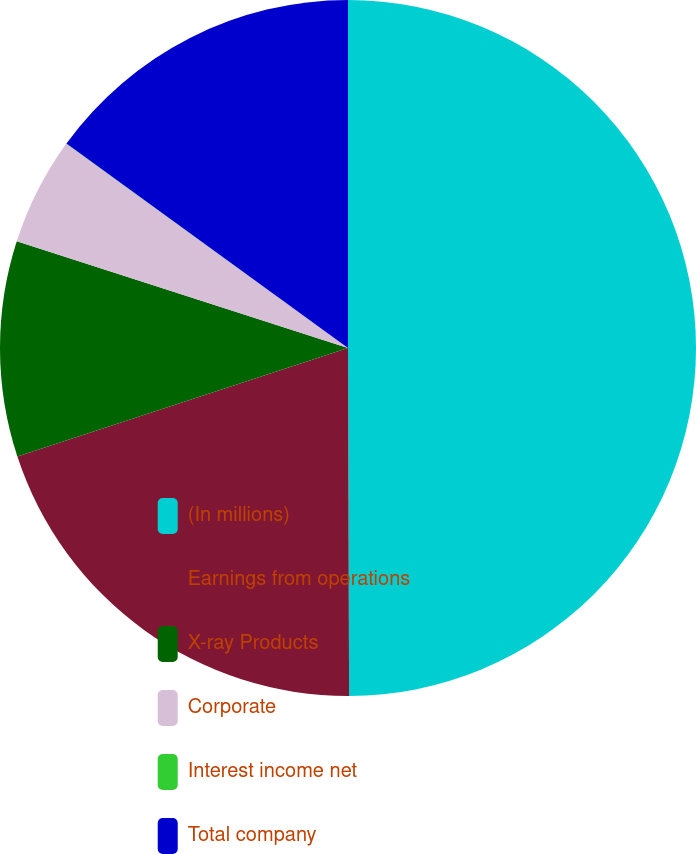Convert chart to OTSL. <chart><loc_0><loc_0><loc_500><loc_500><pie_chart><fcel>(In millions)<fcel>Earnings from operations<fcel>X-ray Products<fcel>Corporate<fcel>Interest income net<fcel>Total company<nl><fcel>49.95%<fcel>20.0%<fcel>10.01%<fcel>5.02%<fcel>0.02%<fcel>15.0%<nl></chart> 